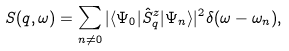Convert formula to latex. <formula><loc_0><loc_0><loc_500><loc_500>S ( q , \omega ) = \sum _ { n \ne 0 } | \langle \Psi _ { 0 } | \hat { S } _ { q } ^ { z } | \Psi _ { n } \rangle | ^ { 2 } \delta ( \omega - \omega _ { n } ) ,</formula> 